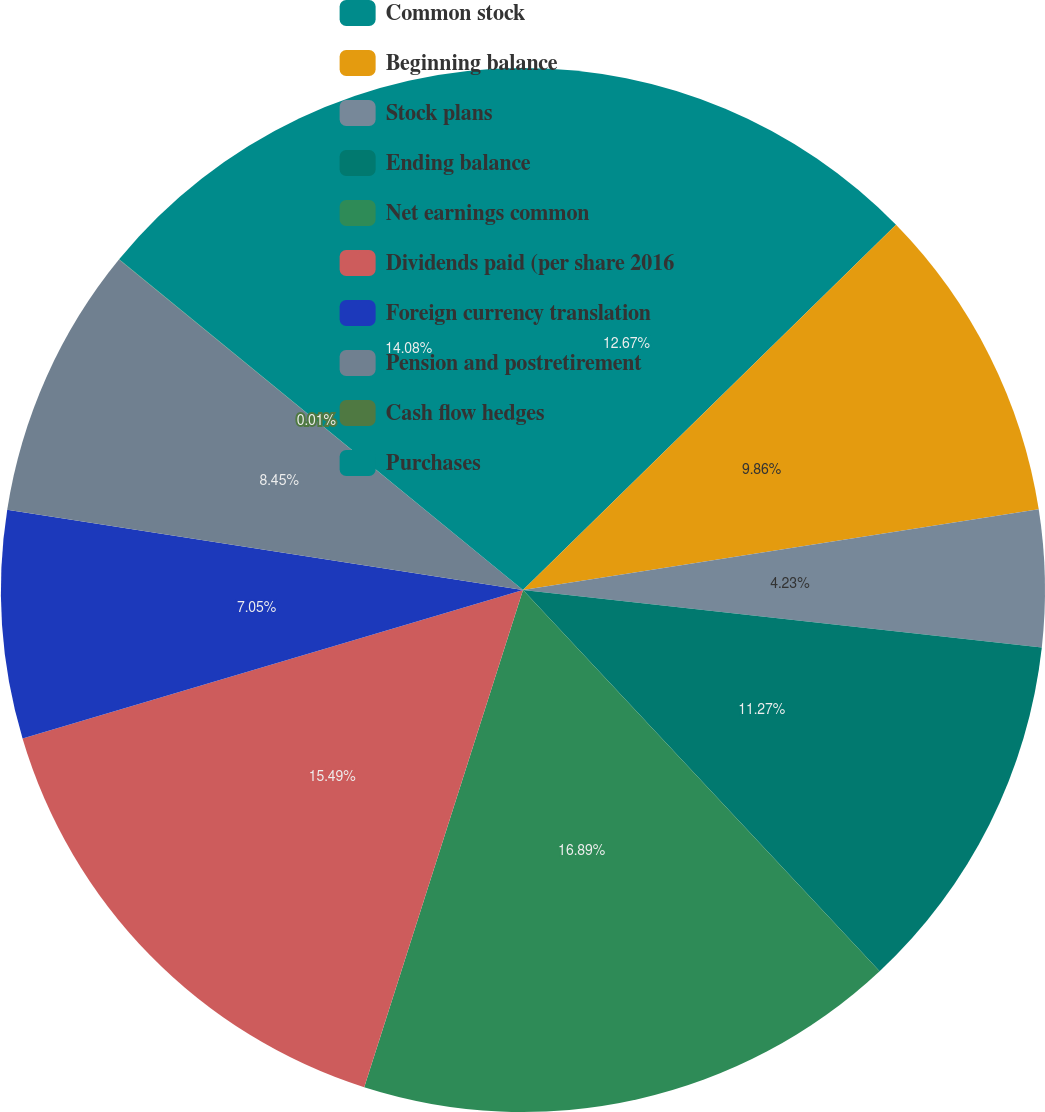Convert chart. <chart><loc_0><loc_0><loc_500><loc_500><pie_chart><fcel>Common stock<fcel>Beginning balance<fcel>Stock plans<fcel>Ending balance<fcel>Net earnings common<fcel>Dividends paid (per share 2016<fcel>Foreign currency translation<fcel>Pension and postretirement<fcel>Cash flow hedges<fcel>Purchases<nl><fcel>12.67%<fcel>9.86%<fcel>4.23%<fcel>11.27%<fcel>16.89%<fcel>15.49%<fcel>7.05%<fcel>8.45%<fcel>0.01%<fcel>14.08%<nl></chart> 